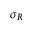<formula> <loc_0><loc_0><loc_500><loc_500>\sigma _ { R }</formula> 